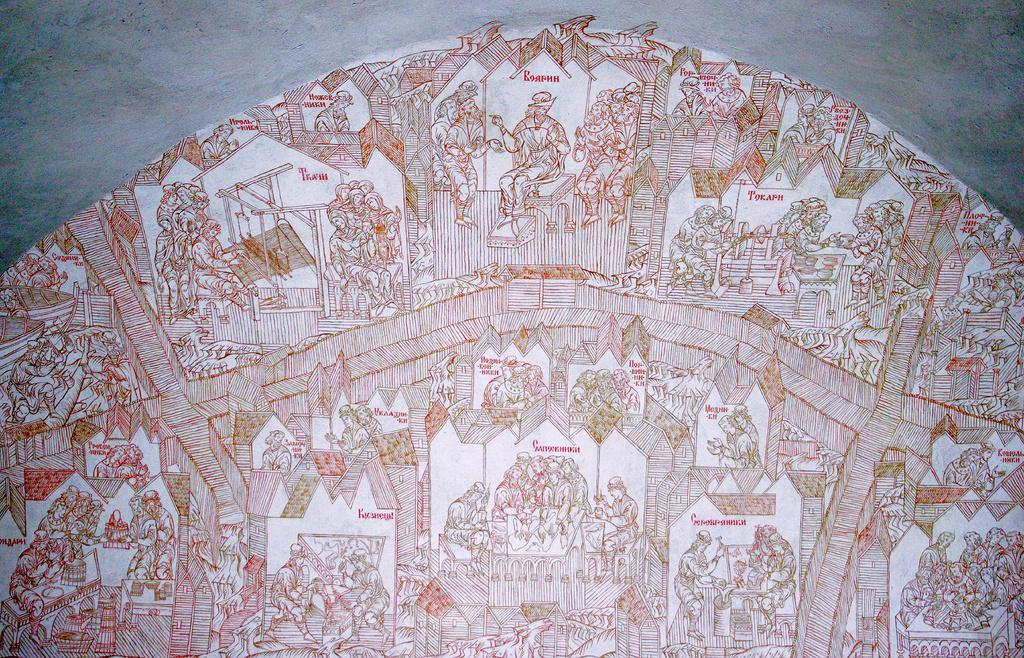What can be seen on the wall in the image? There are many pictures drawn on the wall in the image. Can you describe the type of artwork on the wall? The provided facts do not specify the type of artwork, only that there are many pictures drawn on the wall. How does the presence of these pictures affect the appearance of the wall? The presence of these pictures adds visual interest and color to the wall. How does the experience of the artist who drew the pictures on the wall increase over time? The provided facts do not mention any artist or their experience, so it is impossible to determine how their experience might increase over time. 